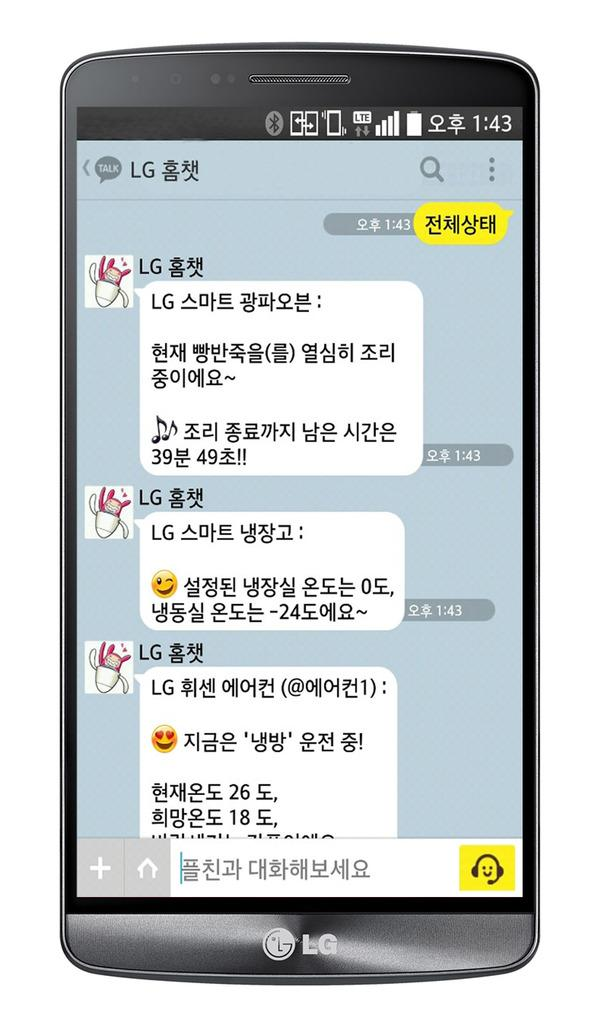<image>
Present a compact description of the photo's key features. An LG cellphone shows on a conversation on the screen in an asian language. 